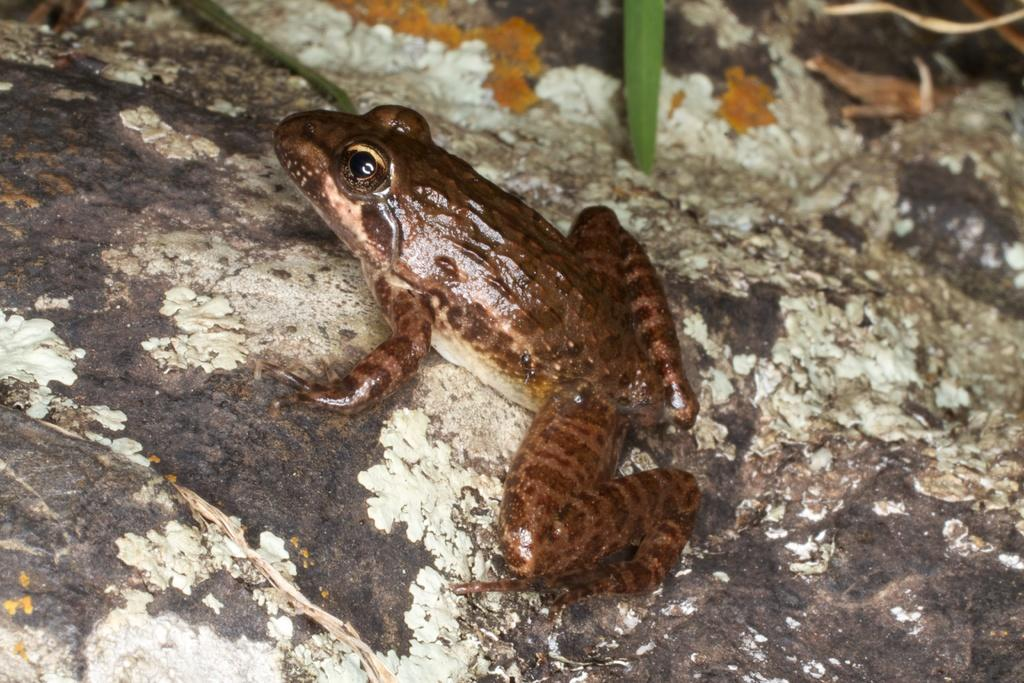What animal is on the stone in the image? There is a frog on a stone in the image. What can be seen at the top of the image? There is a leaf at the top of the image. Who is the expert in the image? There is no expert present in the image; it features a frog on a stone and a leaf. What system is being discussed in the image? There is no system being discussed in the image; it features a frog on a stone and a leaf. 